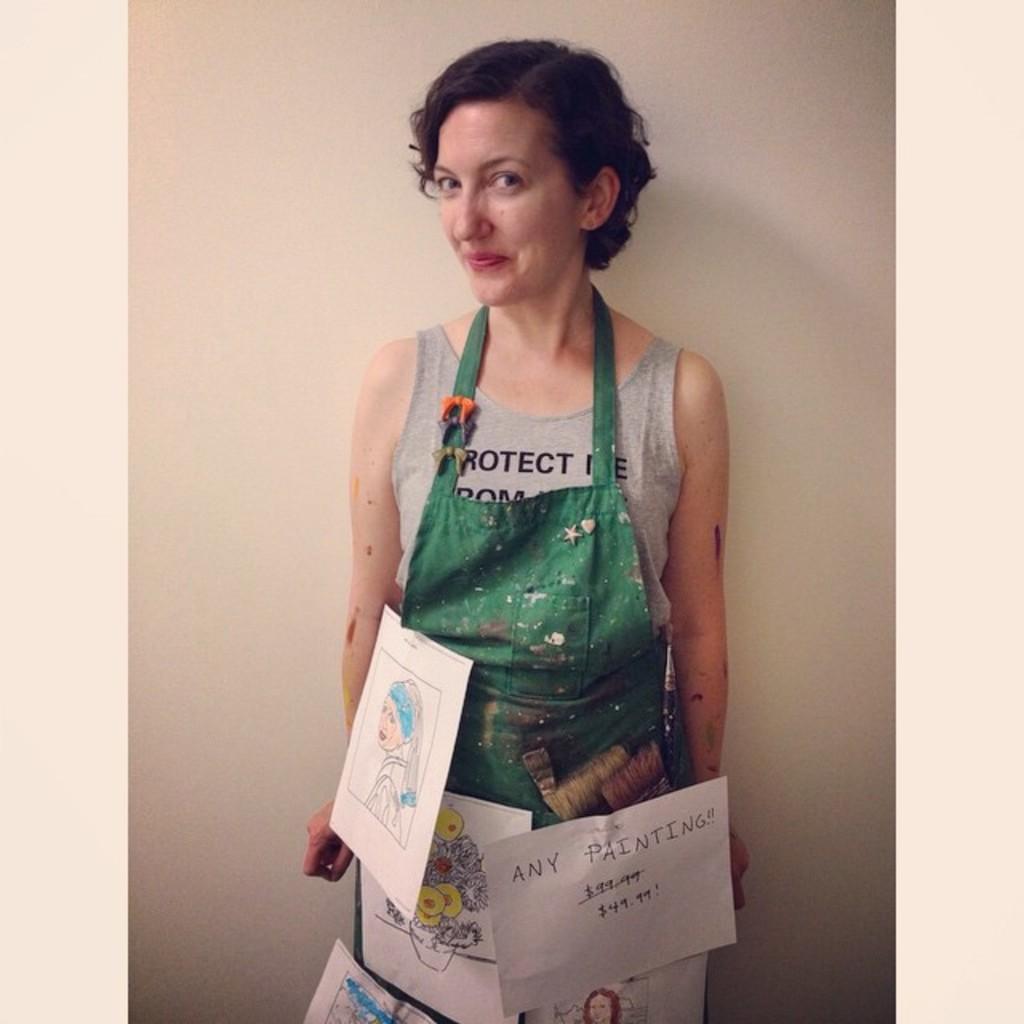Please provide a concise description of this image. There is a woman in gray color t-shirt having different posters on her cloth, smiling and standing. In the background, there is a white wall. 